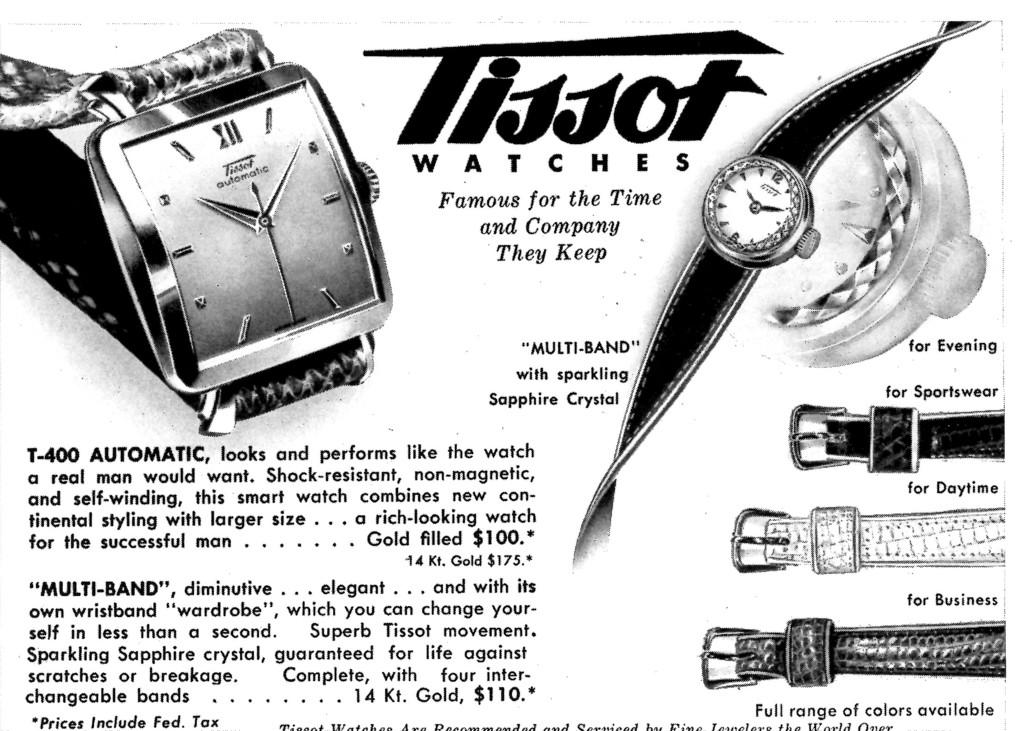Provide a one-sentence caption for the provided image. the article is advertising Tissot watches for various accasions. 